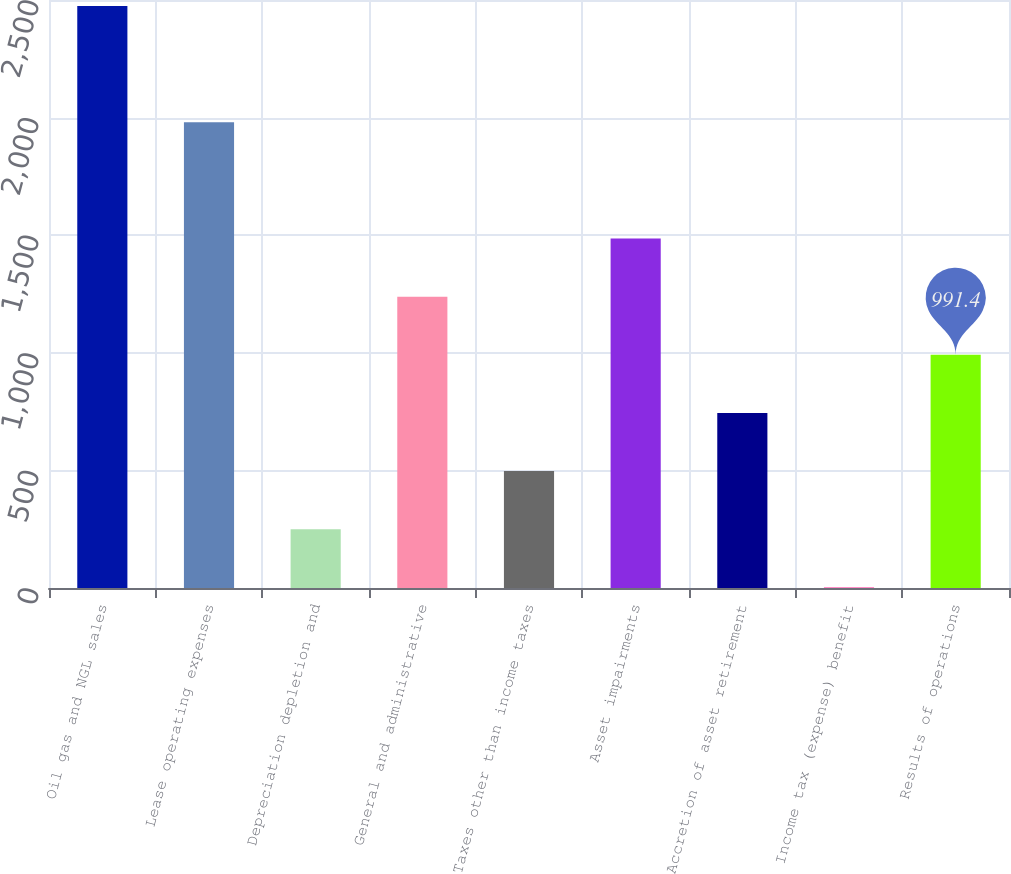Convert chart. <chart><loc_0><loc_0><loc_500><loc_500><bar_chart><fcel>Oil gas and NGL sales<fcel>Lease operating expenses<fcel>Depreciation depletion and<fcel>General and administrative<fcel>Taxes other than income taxes<fcel>Asset impairments<fcel>Accretion of asset retirement<fcel>Income tax (expense) benefit<fcel>Results of operations<nl><fcel>2474<fcel>1979.8<fcel>250.1<fcel>1238.5<fcel>497.2<fcel>1485.6<fcel>744.3<fcel>3<fcel>991.4<nl></chart> 